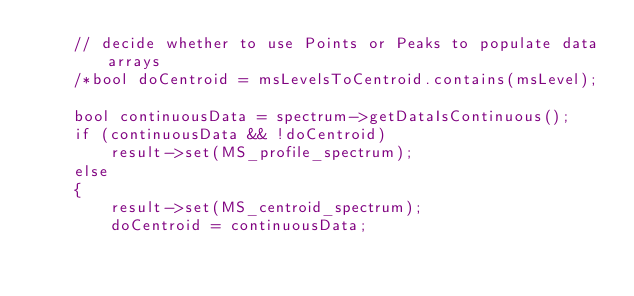<code> <loc_0><loc_0><loc_500><loc_500><_C++_>    // decide whether to use Points or Peaks to populate data arrays
    /*bool doCentroid = msLevelsToCentroid.contains(msLevel);

    bool continuousData = spectrum->getDataIsContinuous();
    if (continuousData && !doCentroid)
        result->set(MS_profile_spectrum);
    else
    {
        result->set(MS_centroid_spectrum);
        doCentroid = continuousData;</code> 